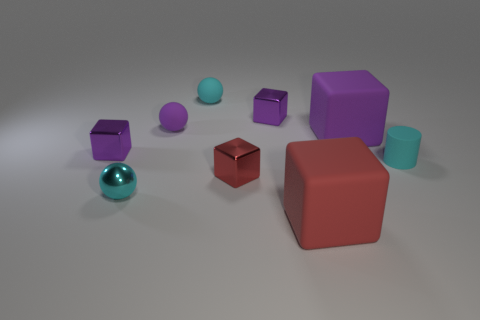There is a small purple shiny thing in front of the shiny thing behind the big block that is behind the small cylinder; what shape is it? cube 